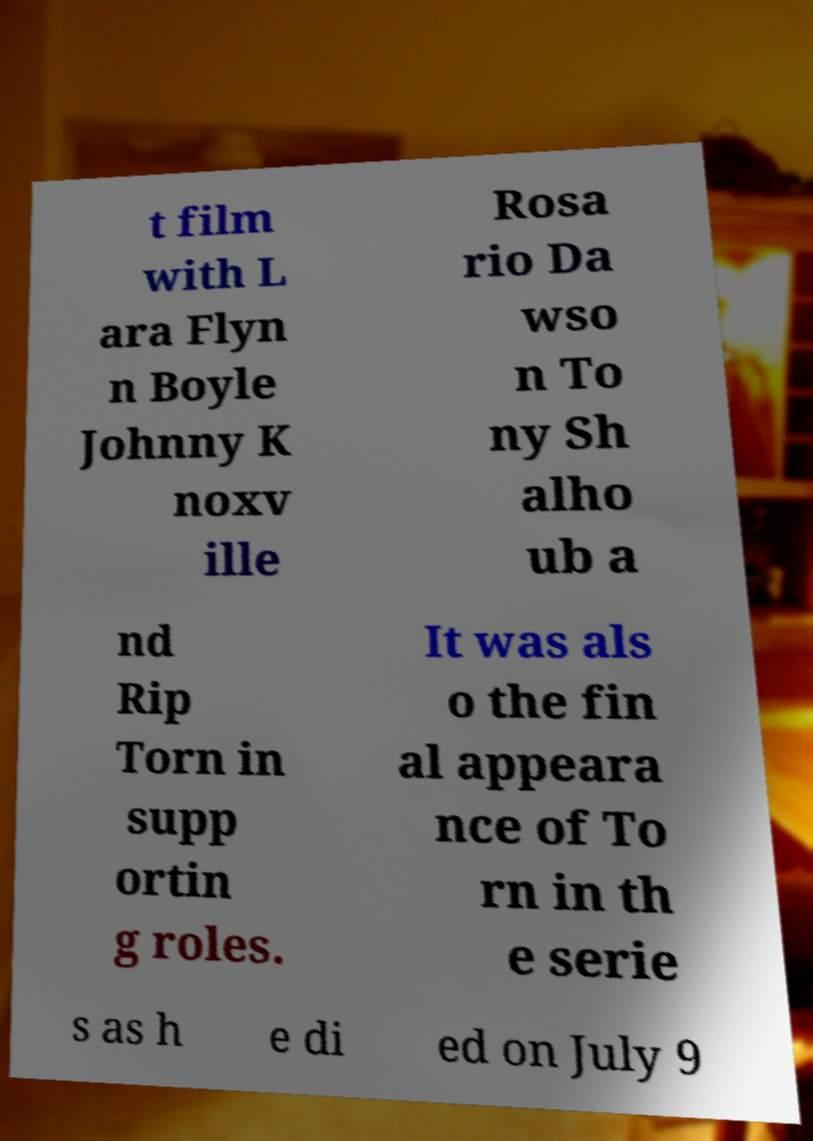Please read and relay the text visible in this image. What does it say? t film with L ara Flyn n Boyle Johnny K noxv ille Rosa rio Da wso n To ny Sh alho ub a nd Rip Torn in supp ortin g roles. It was als o the fin al appeara nce of To rn in th e serie s as h e di ed on July 9 